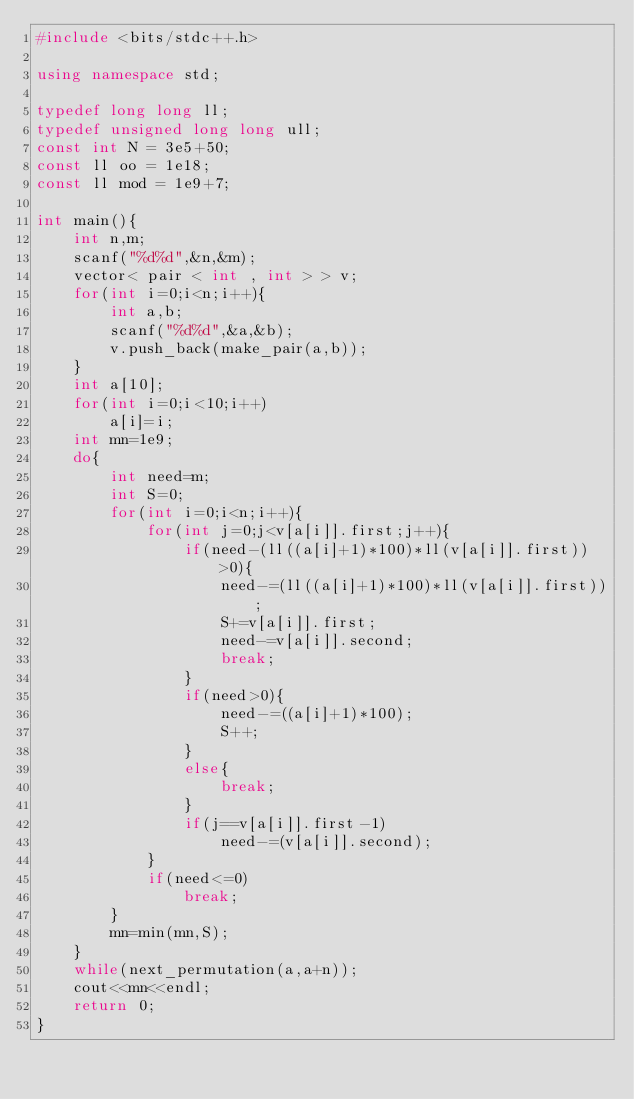<code> <loc_0><loc_0><loc_500><loc_500><_C++_>#include <bits/stdc++.h>

using namespace std;

typedef long long ll;
typedef unsigned long long ull;
const int N = 3e5+50;
const ll oo = 1e18;
const ll mod = 1e9+7;

int main(){
    int n,m;
    scanf("%d%d",&n,&m);
    vector< pair < int , int > > v;
    for(int i=0;i<n;i++){
        int a,b;
        scanf("%d%d",&a,&b);
        v.push_back(make_pair(a,b));
    }
    int a[10];
    for(int i=0;i<10;i++)
        a[i]=i;
    int mn=1e9;
    do{
        int need=m;
        int S=0;
        for(int i=0;i<n;i++){
            for(int j=0;j<v[a[i]].first;j++){
                if(need-(ll((a[i]+1)*100)*ll(v[a[i]].first))>0){
                    need-=(ll((a[i]+1)*100)*ll(v[a[i]].first));
                    S+=v[a[i]].first;
                    need-=v[a[i]].second;
                    break;
                }
                if(need>0){
                    need-=((a[i]+1)*100);
                    S++;
                }
                else{
                    break;
                }
                if(j==v[a[i]].first-1)
                    need-=(v[a[i]].second);
            }
            if(need<=0)
                break;
        }
        mn=min(mn,S);
    }
    while(next_permutation(a,a+n));
    cout<<mn<<endl;
    return 0;
}
</code> 